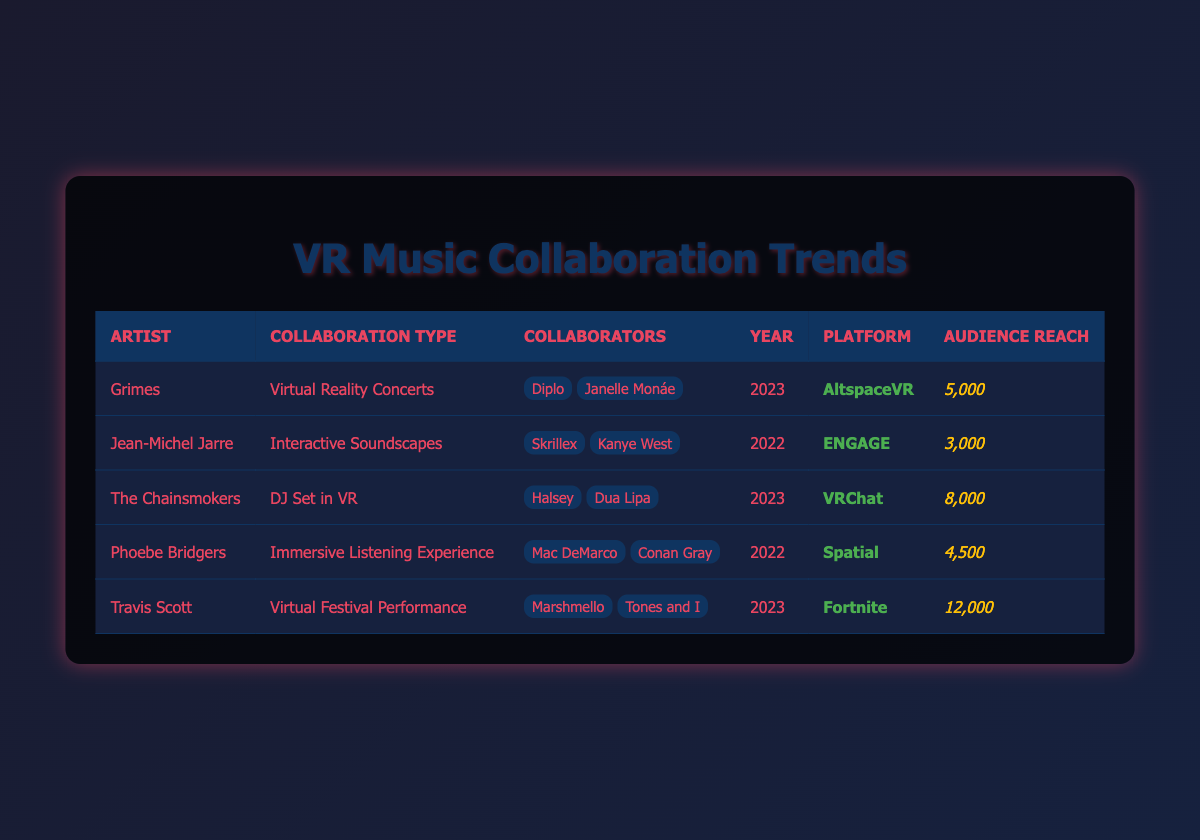What is the collaboration type for Travis Scott? The table lists "Virtual Festival Performance" as the collaboration type associated with Travis Scott. This information is found in the corresponding row of the table.
Answer: Virtual Festival Performance Which artist had the highest audience reach in 2023? In 2023, the audience reaches are: Grimes with 5000, The Chainsmokers with 8000, and Travis Scott with 12000. The highest among these is Travis Scott with an audience reach of 12000.
Answer: Travis Scott How many unique collaborators were involved in the projects listed? The collaborators from the table include: Diplo, Janelle Monáe, Skrillex, Kanye West, Halsey, Dua Lipa, Mac DeMarco, Conan Gray, Marshmello, and Tones and I. Counting these, we find a total of 10 unique collaborators.
Answer: 10 What is the average audience reach for collaborations in 2022? The audience reaches for 2022 are 3000 (Jean-Michel Jarre) and 4500 (Phoebe Bridgers). Adding these gives 3000 + 4500 = 7500. Dividing by 2, the average audience reach is 7500 / 2 = 3750.
Answer: 3750 Did any collaboration on VRChat occur in 2022? Reviewing the table, there is no entry for 2022 that indicates a collaboration in VRChat, as The Chainsmokers in 2023 is the only entry for that platform. Therefore, the answer is no.
Answer: No Which artist collaborated with the most artists in 2023 and how many were they? In 2023, both Grimes and The Chainsmokers collaborated with 2 artists each. Travis Scott also had 2 collaborators. Therefore, they all equally collaborated with the same number of artists.
Answer: 2 Is there a collaboration in Spatial for 2023? Checking the table, the only collaboration listed in Spatial is by Phoebe Bridgers in 2022. Thus, there is no collaboration in Spatial for 2023.
Answer: No What is the total number of audience reach across all collaborations? Summing the audience reaches: 5000 + 3000 + 8000 + 4500 + 12000 equals 32000. Therefore, the total audience reach across all collaborations is 32000.
Answer: 32000 How many collaborations included the artist Halsey? According to the table, Halsey is listed as a collaborator with The Chainsmokers in their 2023 VR DJ Set. Thus, Halsey participated in one collaboration as per the data provided.
Answer: 1 